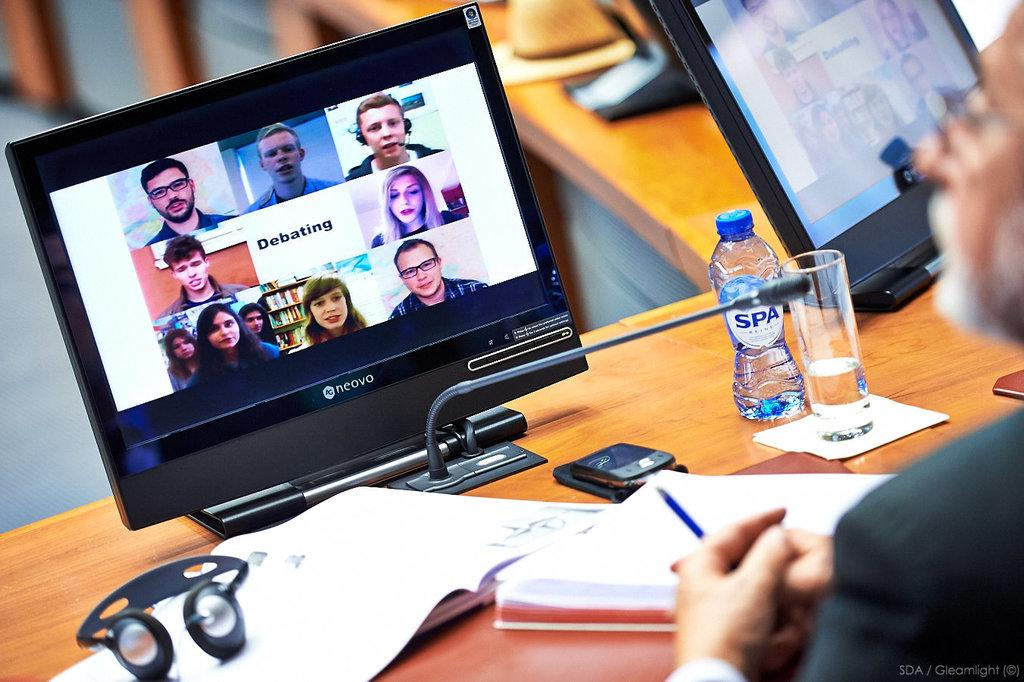<image>
Relay a brief, clear account of the picture shown. A person is watching a screen that has people's faces around the word Debating. 